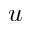<formula> <loc_0><loc_0><loc_500><loc_500>u</formula> 